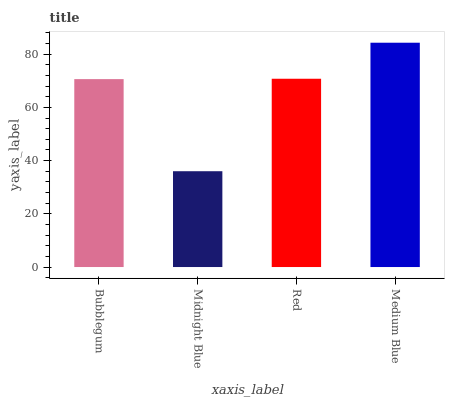Is Red the minimum?
Answer yes or no. No. Is Red the maximum?
Answer yes or no. No. Is Red greater than Midnight Blue?
Answer yes or no. Yes. Is Midnight Blue less than Red?
Answer yes or no. Yes. Is Midnight Blue greater than Red?
Answer yes or no. No. Is Red less than Midnight Blue?
Answer yes or no. No. Is Red the high median?
Answer yes or no. Yes. Is Bubblegum the low median?
Answer yes or no. Yes. Is Midnight Blue the high median?
Answer yes or no. No. Is Midnight Blue the low median?
Answer yes or no. No. 